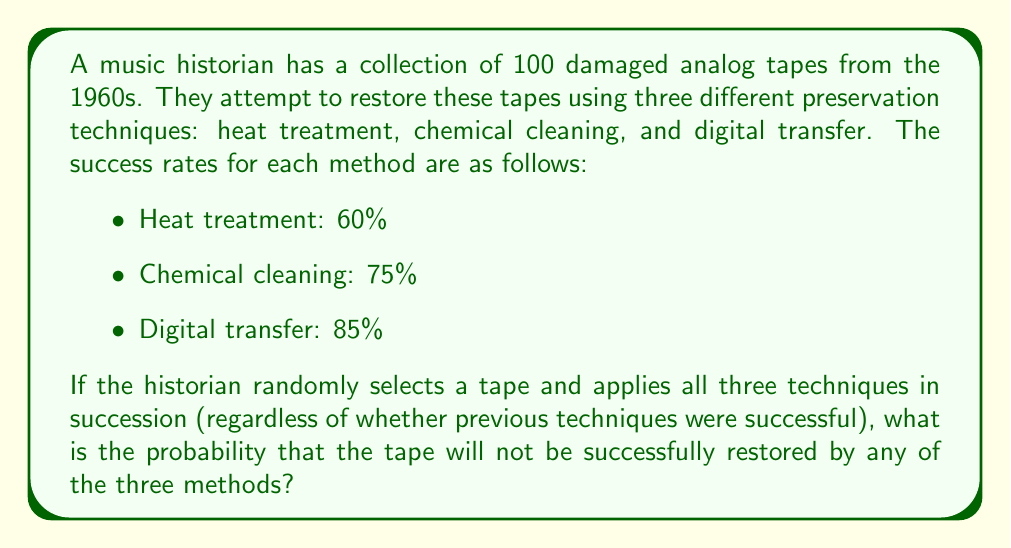Provide a solution to this math problem. Let's approach this step-by-step:

1) First, we need to calculate the probability of failure for each method:
   - Heat treatment failure: $1 - 0.60 = 0.40$ or $40\%$
   - Chemical cleaning failure: $1 - 0.75 = 0.25$ or $25\%$
   - Digital transfer failure: $1 - 0.85 = 0.15$ or $15\%$

2) For the tape to not be restored, it must fail all three methods. Since the methods are applied independently, we can multiply the probabilities of failure for each method:

   $$P(\text{not restored}) = P(\text{heat fails}) \times P(\text{chemical fails}) \times P(\text{digital fails})$$

3) Substituting the values:

   $$P(\text{not restored}) = 0.40 \times 0.25 \times 0.15$$

4) Calculating:

   $$P(\text{not restored}) = 0.015 = 1.5\%$$

Therefore, the probability that a randomly selected tape will not be successfully restored by any of the three methods is 0.015 or 1.5%.
Answer: 0.015 